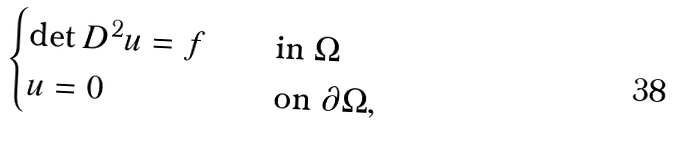<formula> <loc_0><loc_0><loc_500><loc_500>\begin{cases} \det D ^ { 2 } u = f \quad & \text {in $\Omega$} \\ u = 0 & \text {on $\partial \Omega$} , \end{cases}</formula> 